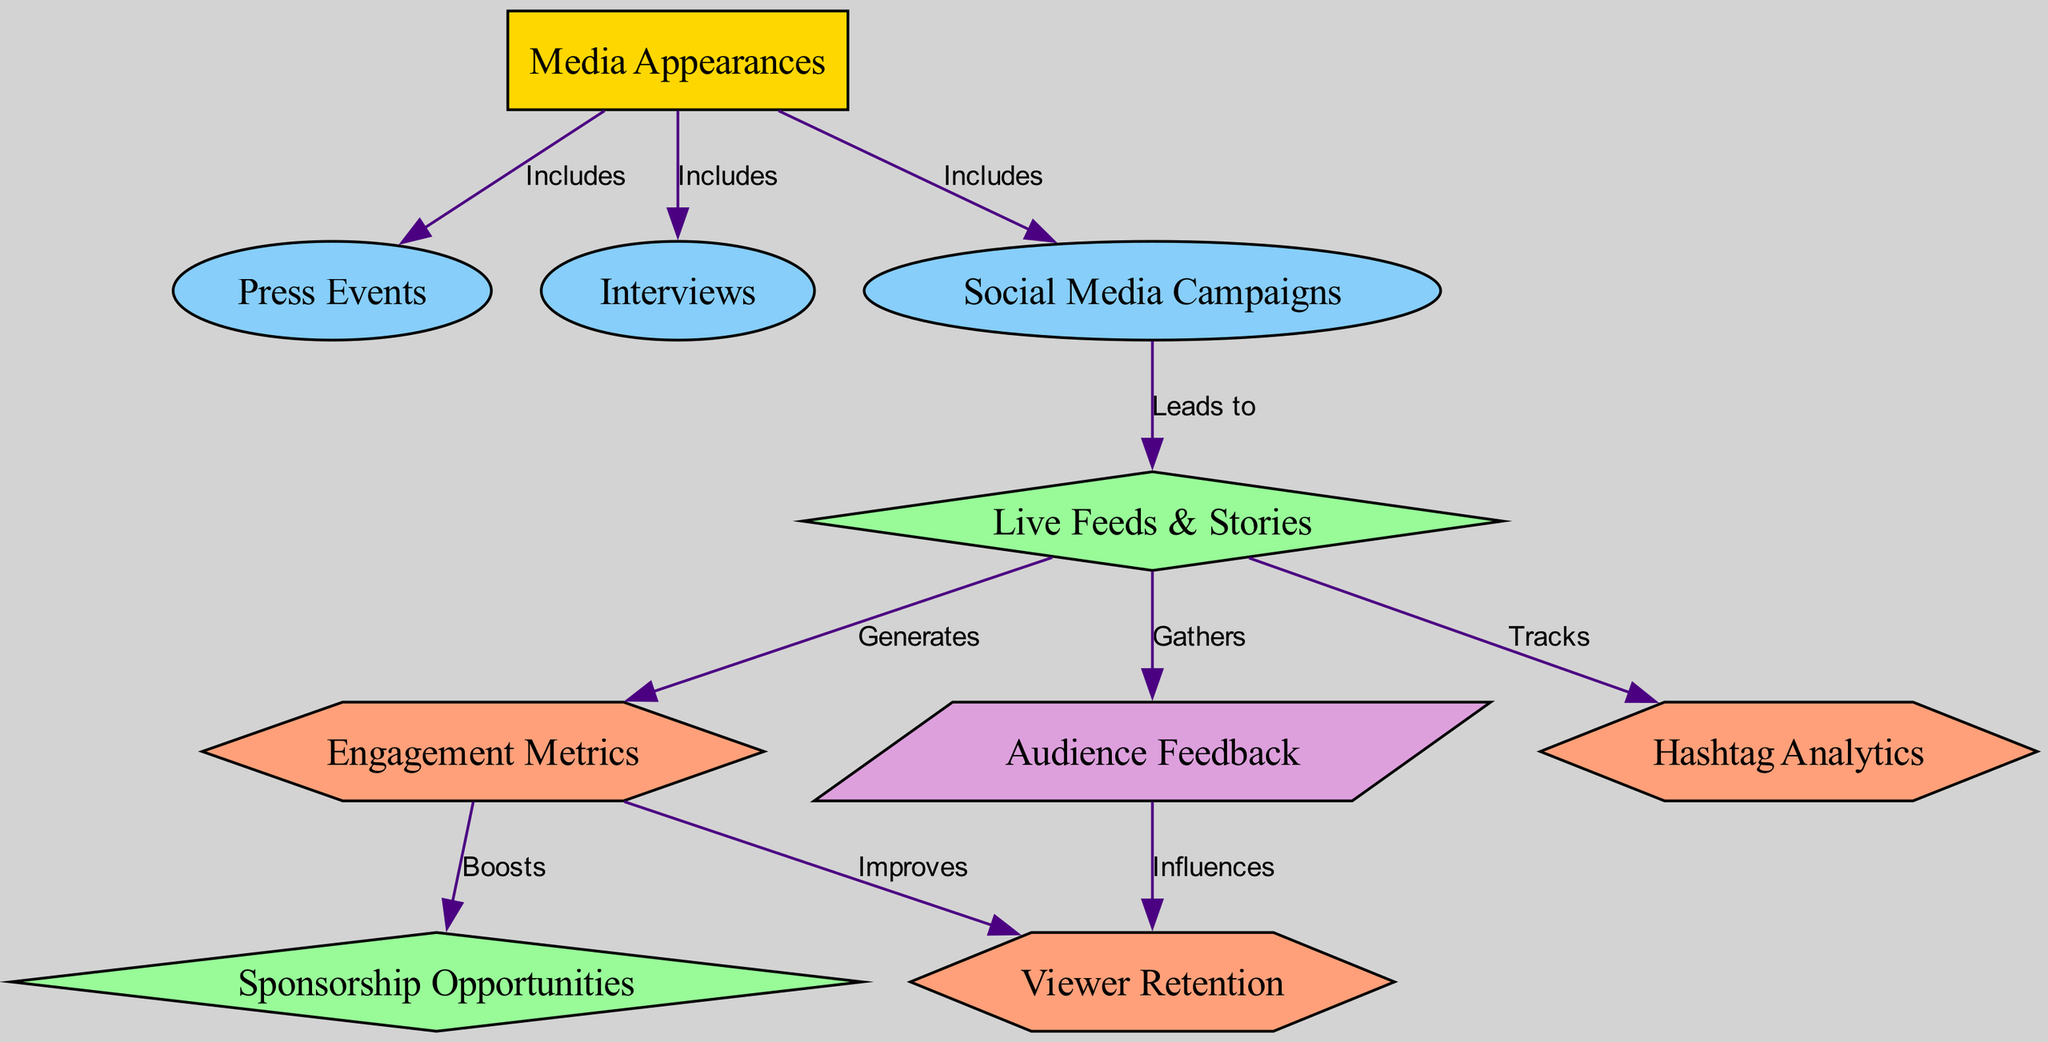What is the main category represented at the top of the diagram? The main category at the top is the node labeled "Media Appearances," which is the root node from which other processes and outcomes branch out.
Answer: Media Appearances How many processes are included in the media outreach impact? The diagram shows three distinct processes, namely "Press Events," "Interviews," and "Social Media Campaigns," which are connected to the root node.
Answer: Three Which outcome is generated from live feeds and stories? The outcome generated from "Live Feeds & Stories" is the metric "Engagement Metrics," indicating the effectiveness of the outreach through these feeds.
Answer: Engagement Metrics What type of relationship exists between engagement metrics and sponsorship opportunities? The relationship is that "Engagement Metrics" boosts "Sponsorship Opportunities," illustrating how metrics can enhance potential sponsorships.
Answer: Boosts What feedback metric influences viewer retention? The feedback metric that influences "Viewer Retention" is "Audience Feedback," showing a direct link between audience responses and retention rates.
Answer: Audience Feedback Which two processes lead to live feeds and stories? The two processes that lead to "Live Feeds & Stories" are "Social Media Campaigns" and the other process is not connected directly to this outcome; thus, only one process leads to it.
Answer: Social Media Campaigns How are engagement metrics and viewer retention related? Both "Engagement Metrics" and "Viewer Retention" are influenced by "Engagement Metrics" through an improvement process indicated in the diagram.
Answer: Improves What type of node is located between social media campaigns and live feeds & stories? The node located between "Social Media Campaigns" and "Live Feeds & Stories" is of type "outcome," signifying the result of social media efforts.
Answer: Outcome 